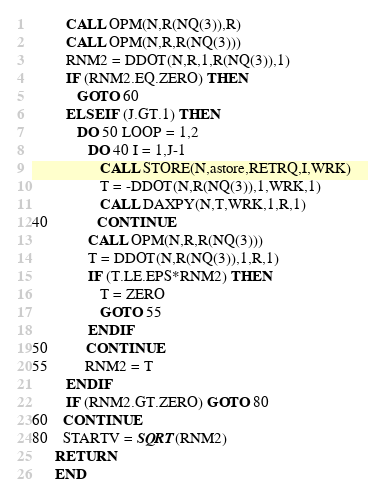Convert code to text. <code><loc_0><loc_0><loc_500><loc_500><_FORTRAN_>         CALL OPM(N,R(NQ(3)),R)
         CALL OPM(N,R,R(NQ(3)))
         RNM2 = DDOT(N,R,1,R(NQ(3)),1)
         IF (RNM2.EQ.ZERO) THEN
            GOTO 60
         ELSE IF (J.GT.1) THEN
            DO 50 LOOP = 1,2
               DO 40 I = 1,J-1
                  CALL STORE(N,astore,RETRQ,I,WRK)
                  T = -DDOT(N,R(NQ(3)),1,WRK,1)
                  CALL DAXPY(N,T,WRK,1,R,1)
40             CONTINUE
               CALL OPM(N,R,R(NQ(3)))
               T = DDOT(N,R(NQ(3)),1,R,1)
               IF (T.LE.EPS*RNM2) THEN
                  T = ZERO
                  GOTO 55
               ENDIF
50          CONTINUE
55          RNM2 = T
         ENDIF
         IF (RNM2.GT.ZERO) GOTO 80
60    CONTINUE
80    STARTV = SQRT(RNM2)
      RETURN
      END
</code> 